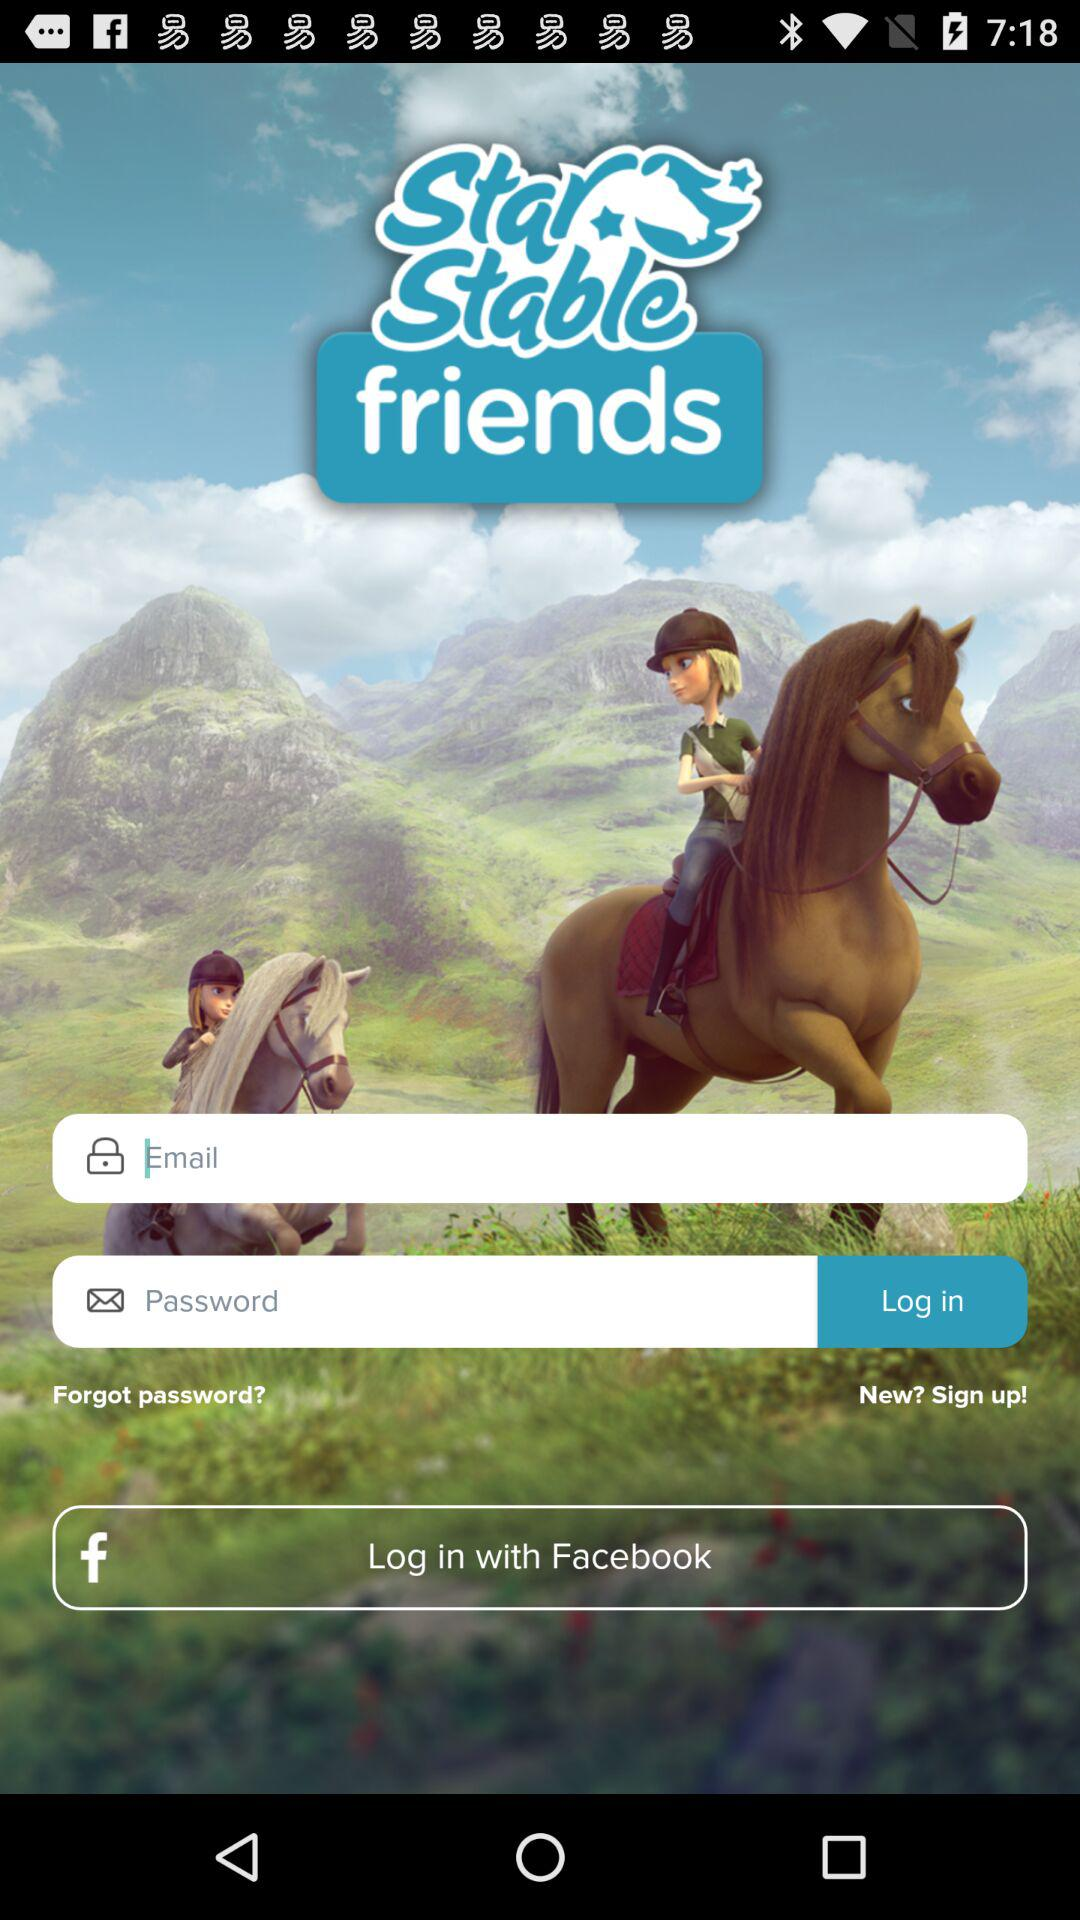From what app can we log in? You can log in with "Facebook". 